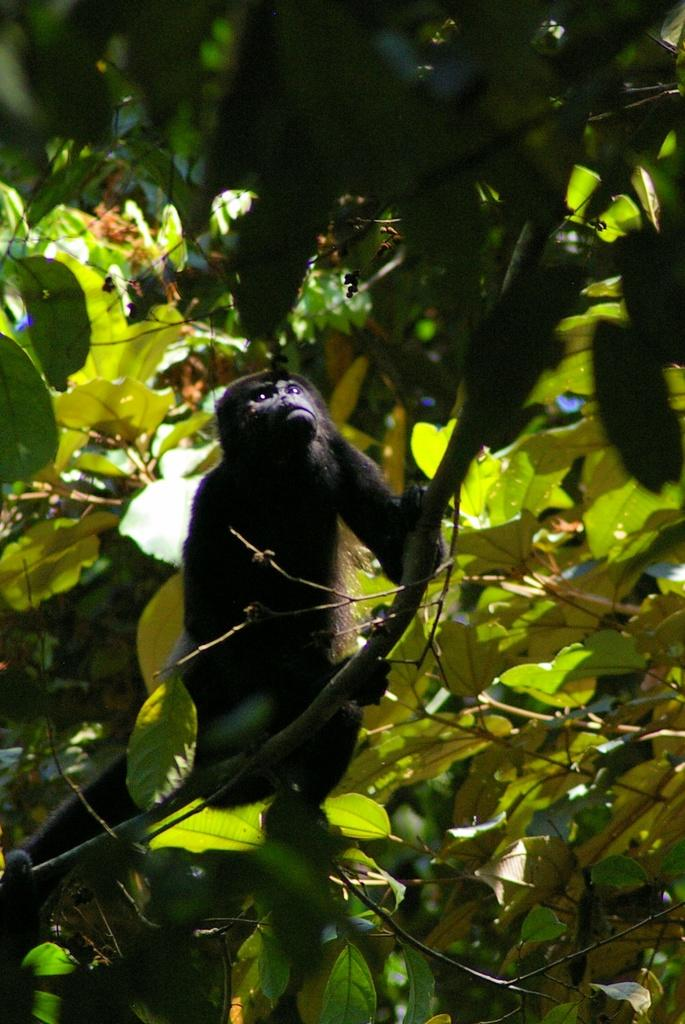What animal is featured in the image? There is a gorilla in the image. Where is the gorilla located in the image? The gorilla is on a branch of a tree. What can be seen on the tree besides the gorilla? There are many leaves on the tree. Is there a mailbox near the gorilla in the image? No, there is no mailbox present in the image. 